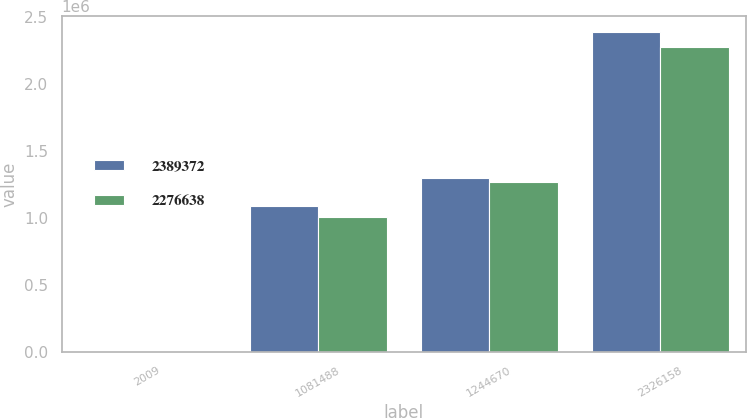Convert chart. <chart><loc_0><loc_0><loc_500><loc_500><stacked_bar_chart><ecel><fcel>2009<fcel>1081488<fcel>1244670<fcel>2326158<nl><fcel>2.38937e+06<fcel>2008<fcel>1.09254e+06<fcel>1.29683e+06<fcel>2.38937e+06<nl><fcel>2.27664e+06<fcel>2007<fcel>1.00554e+06<fcel>1.27109e+06<fcel>2.27664e+06<nl></chart> 